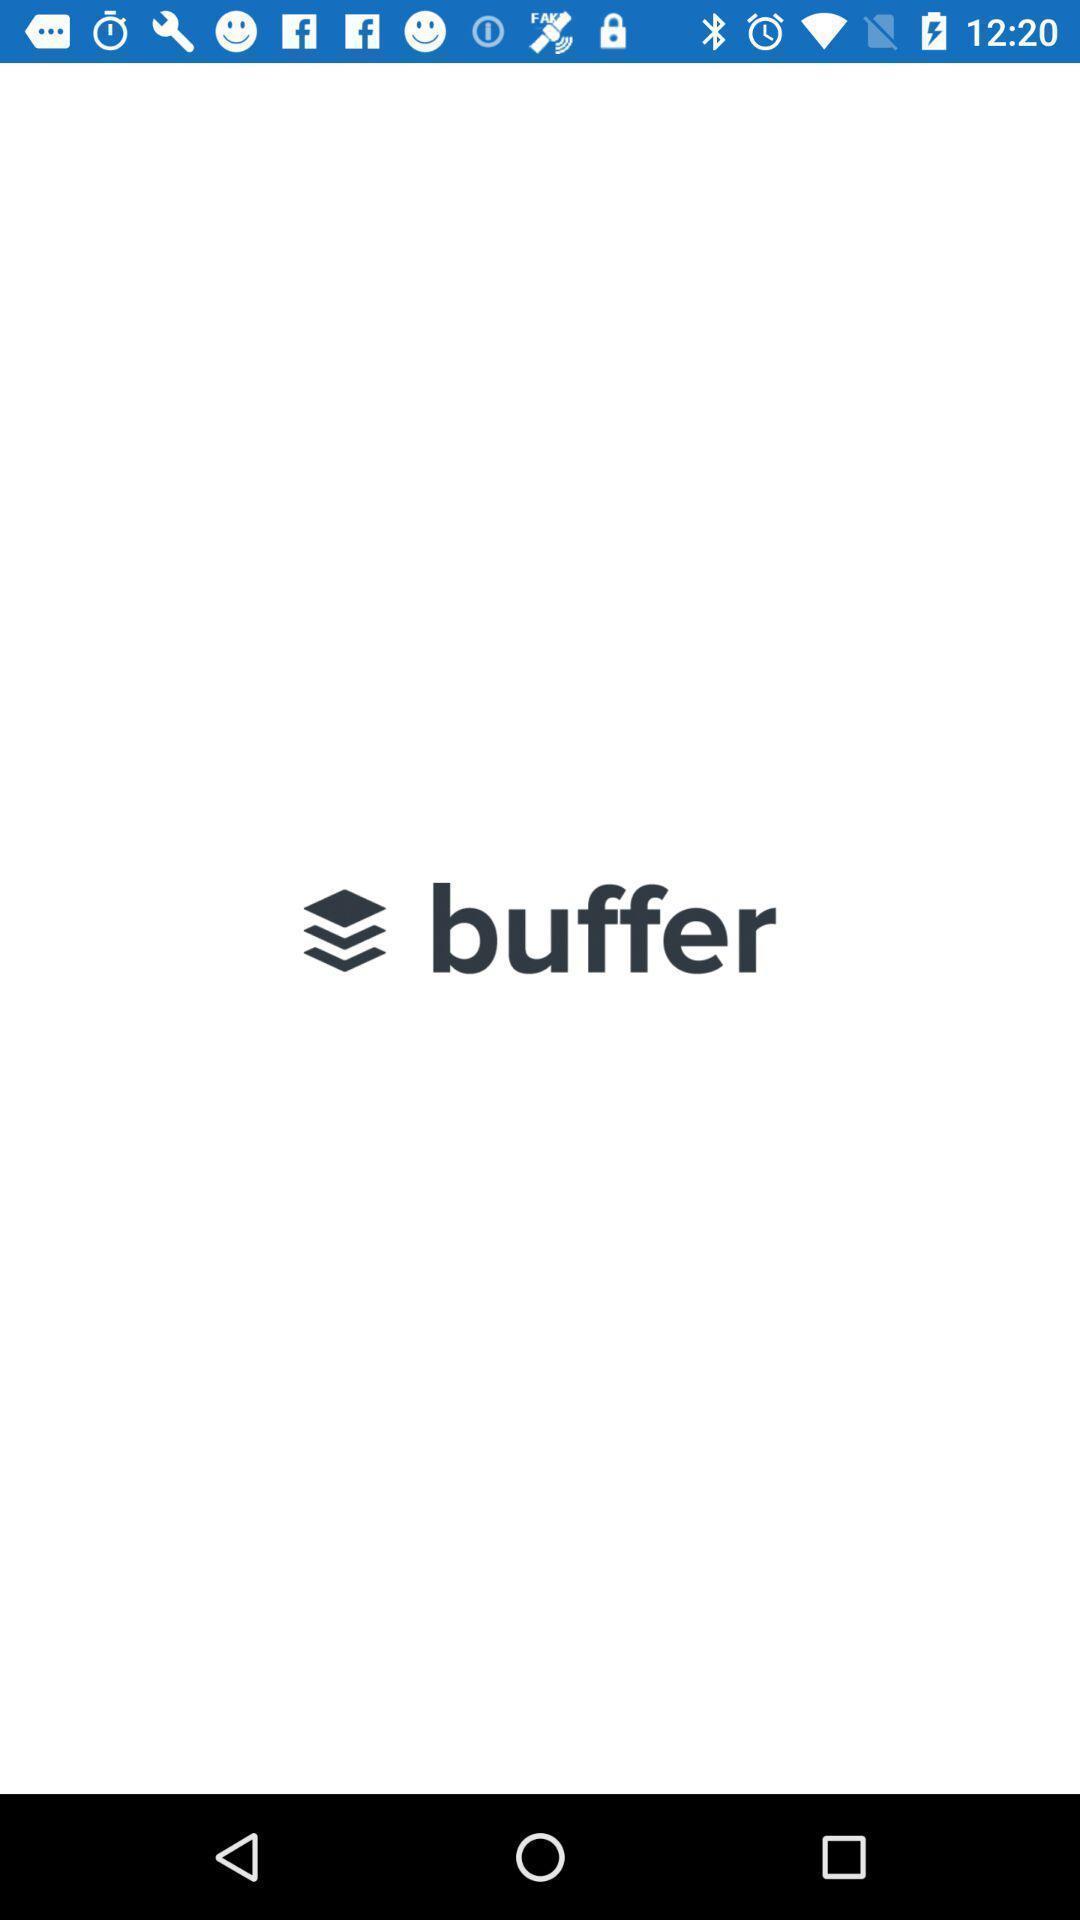Tell me what you see in this picture. Welcome page to the application. 